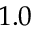Convert formula to latex. <formula><loc_0><loc_0><loc_500><loc_500>1 . 0</formula> 